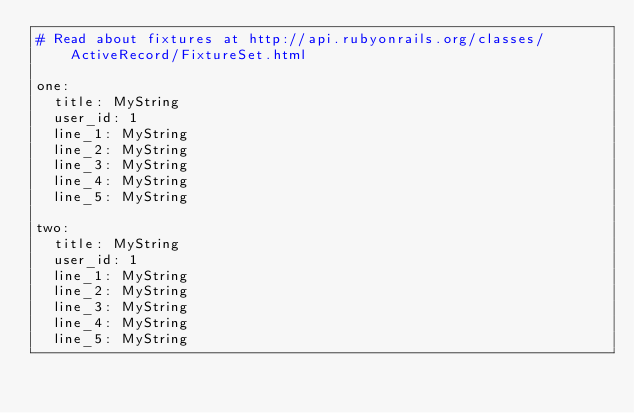Convert code to text. <code><loc_0><loc_0><loc_500><loc_500><_YAML_># Read about fixtures at http://api.rubyonrails.org/classes/ActiveRecord/FixtureSet.html

one:
  title: MyString
  user_id: 1
  line_1: MyString
  line_2: MyString
  line_3: MyString
  line_4: MyString
  line_5: MyString

two:
  title: MyString
  user_id: 1
  line_1: MyString
  line_2: MyString
  line_3: MyString
  line_4: MyString
  line_5: MyString
</code> 